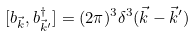<formula> <loc_0><loc_0><loc_500><loc_500>[ b _ { \vec { k } } , b ^ { \dagger } _ { \vec { k } ^ { \prime } } ] = ( 2 \pi ) ^ { 3 } \delta ^ { 3 } ( \vec { k } - \vec { k } ^ { \prime } )</formula> 